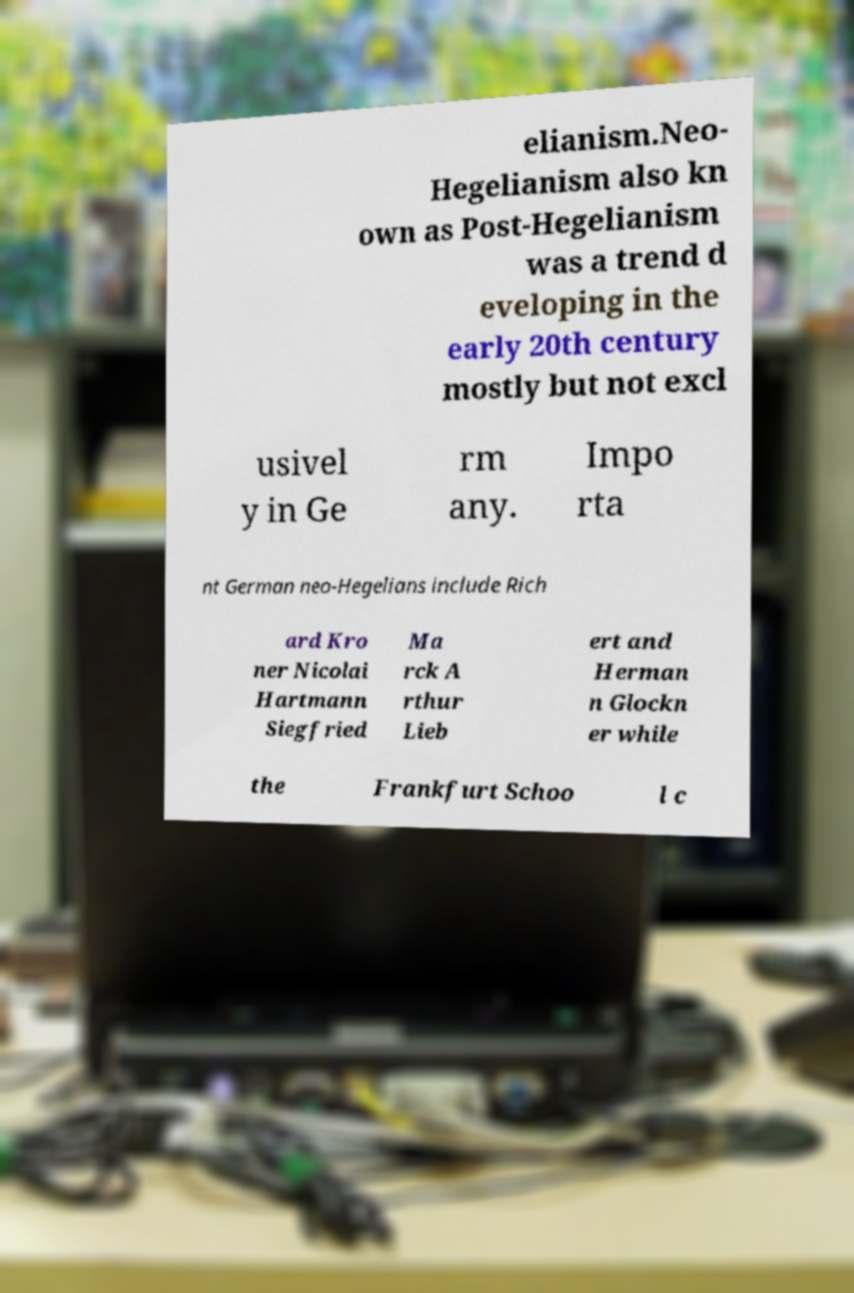Could you extract and type out the text from this image? elianism.Neo- Hegelianism also kn own as Post-Hegelianism was a trend d eveloping in the early 20th century mostly but not excl usivel y in Ge rm any. Impo rta nt German neo-Hegelians include Rich ard Kro ner Nicolai Hartmann Siegfried Ma rck A rthur Lieb ert and Herman n Glockn er while the Frankfurt Schoo l c 